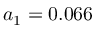<formula> <loc_0><loc_0><loc_500><loc_500>a _ { 1 } = 0 . 0 6 6</formula> 